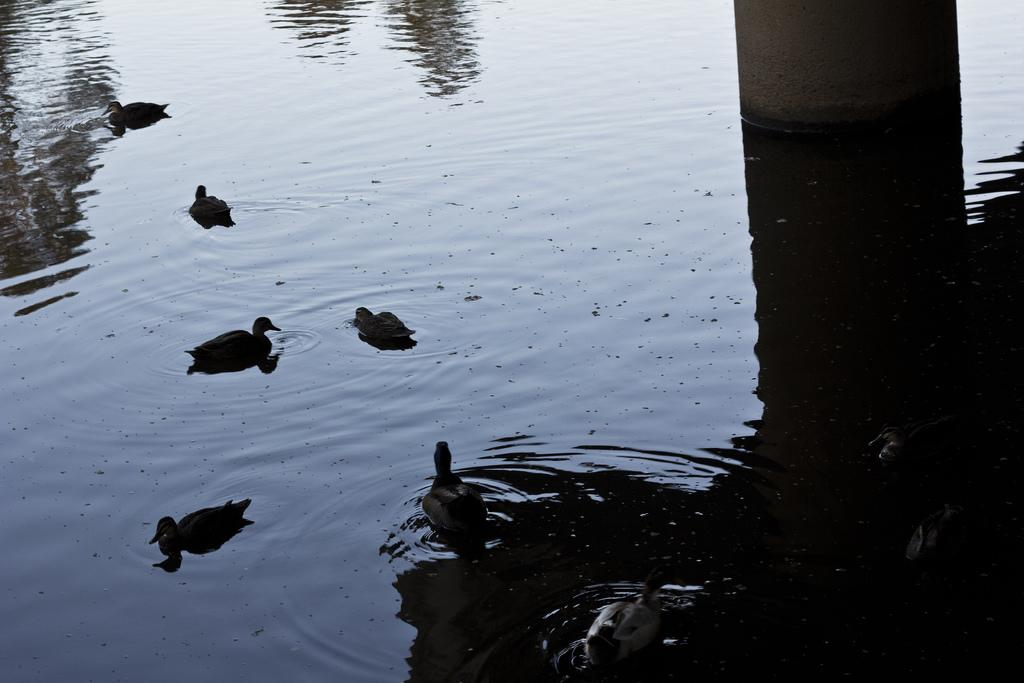What is present in the image that is related to water? There is water in the image. What type of animals can be seen in the image? There are ducks in the image. Can you describe the overall lighting or brightness of the image? The image appears to be slightly dark. What type of brush can be seen in the image? There is no brush present in the image. Is there a plane visible in the image? There is no plane present in the image. 